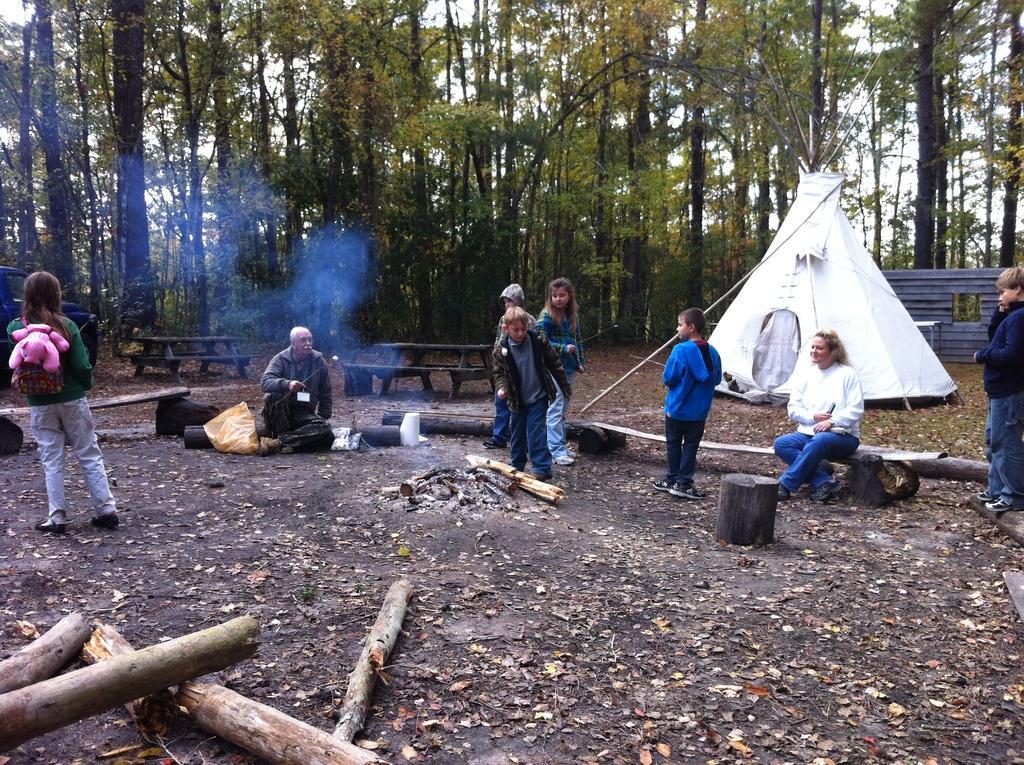In one or two sentences, can you explain what this image depicts? In this image in an open ground there are many people. On the ground there are woods. This is fire place. In the background there is tent, benches, trees. 